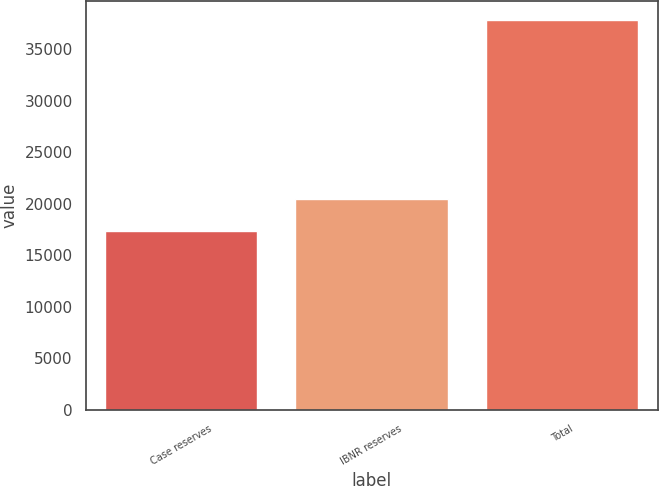Convert chart. <chart><loc_0><loc_0><loc_500><loc_500><bar_chart><fcel>Case reserves<fcel>IBNR reserves<fcel>Total<nl><fcel>17307<fcel>20476<fcel>37783<nl></chart> 